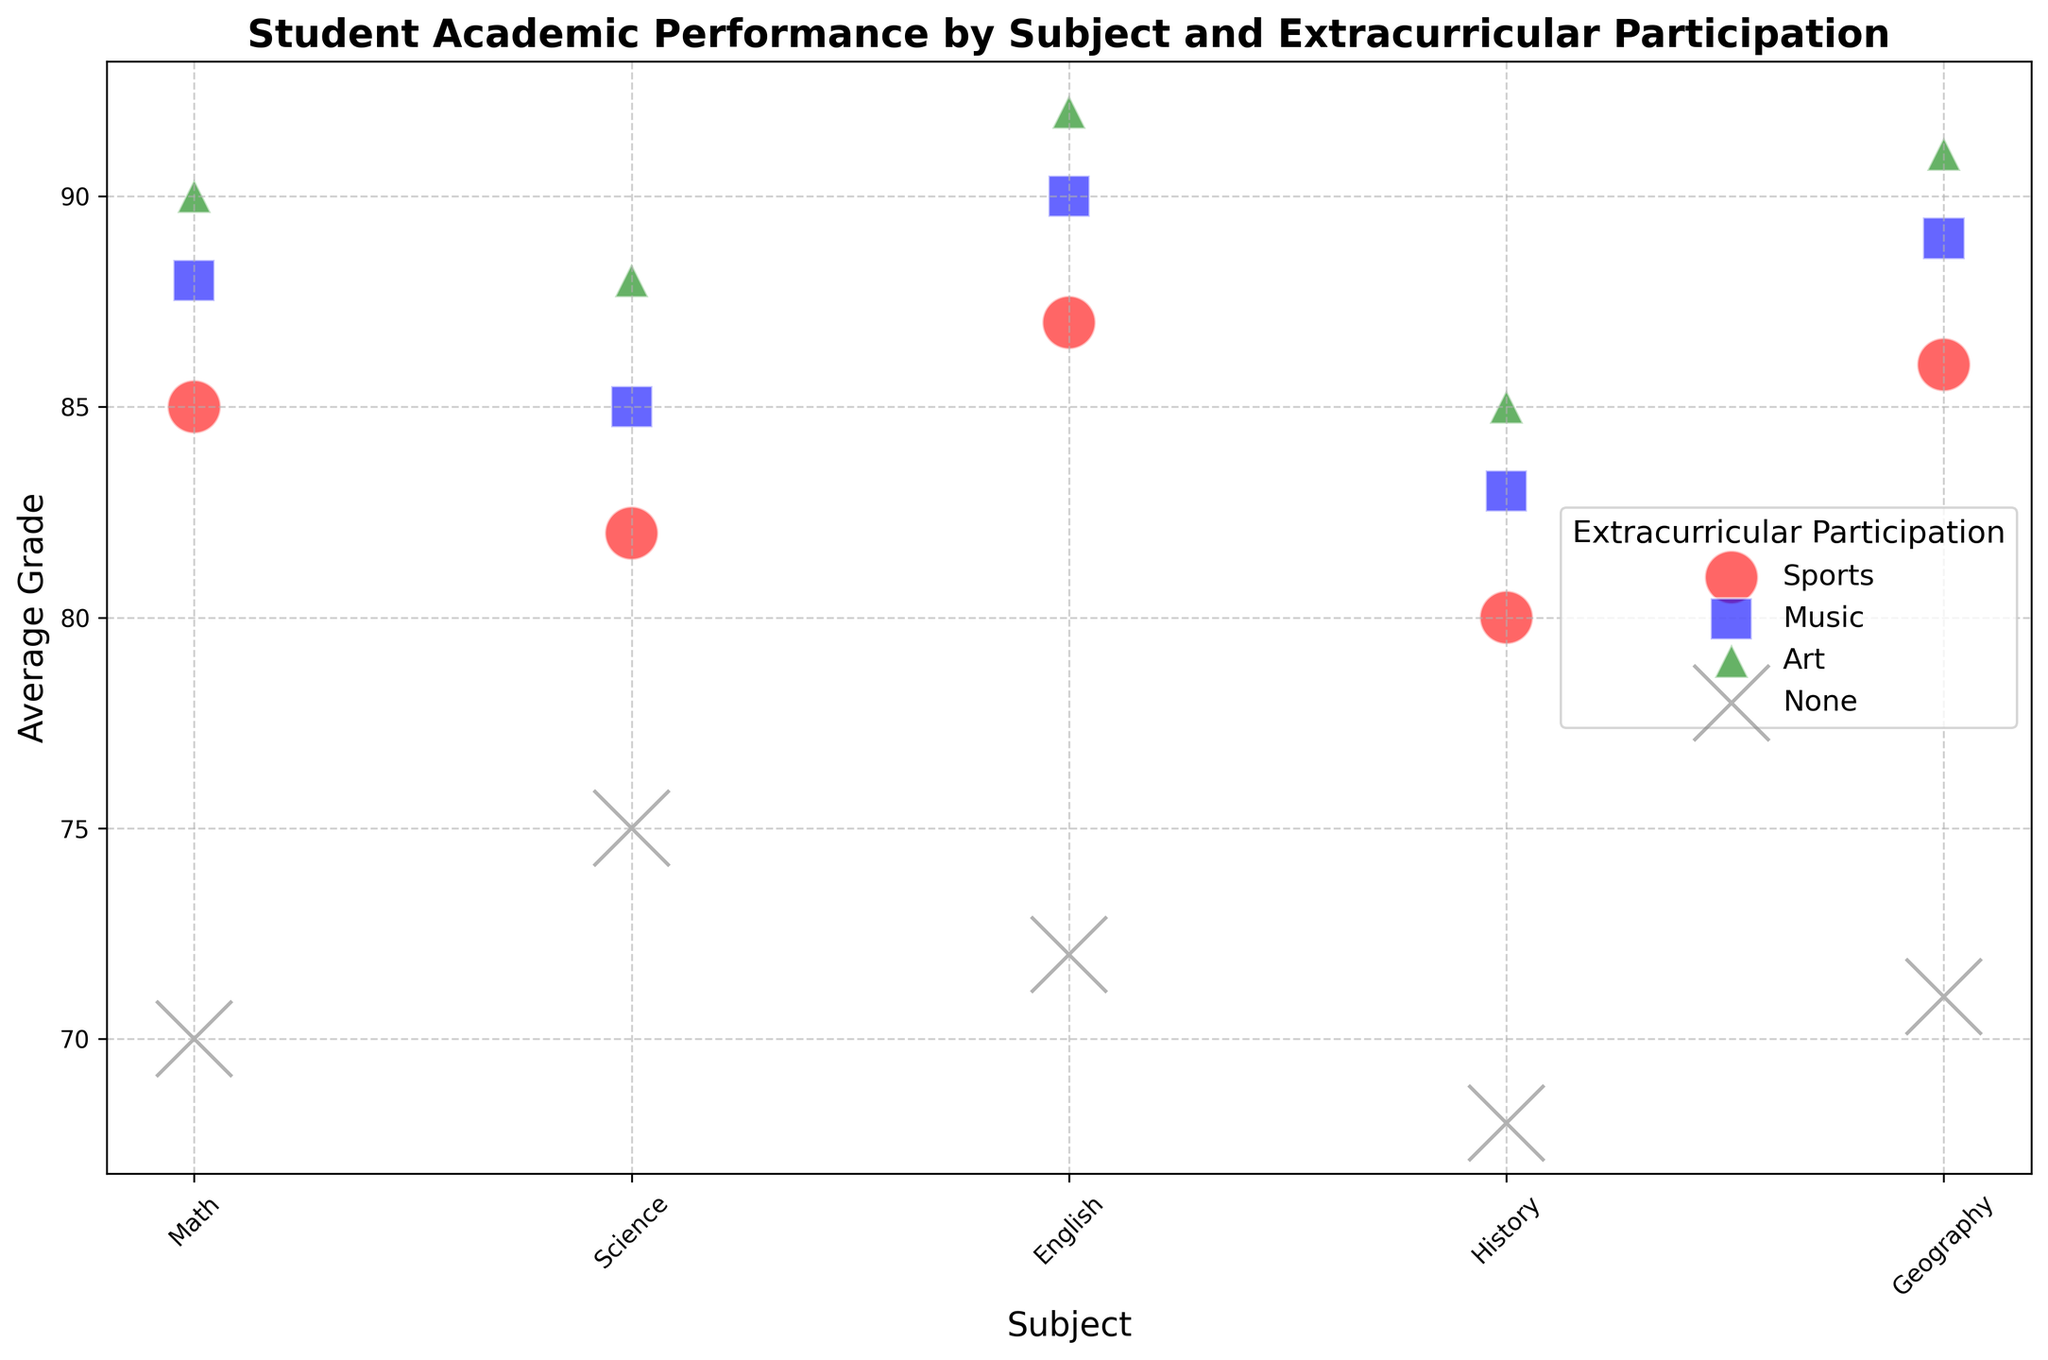Which subject has the highest average grade for students involved in sports? To find this, locate the red bubbles on the chart, which represent sports. Compare their heights (average grades). The highest red bubble on the plot represents English with an average grade of 87.
Answer: English What is the difference in average grades between students participating in art and those not involved in any extracurricular activities for Math? Identify the green (Art) and grey (None) bubbles for Math. The green bubble (Art) has an average grade of 90, and the grey bubble (None) has an average grade of 70. The difference is 90 - 70 = 20.
Answer: 20 Which extracurricular activity shows the lowest average grade for Science? Look at the bubbles for Science and identify the colors: red (Sports), blue (Music), green (Art), and grey (None). The grey (None) bubble has the lowest average grade with a value of 75.
Answer: None If you sum the number of participants involved in Music and Art for History, what is the total? Locate the bubbles for History with blue (Music) and green (Art) colors. Music has 30 participants, and Art has 20 participants. Sum them up: 30 + 20 = 50.
Answer: 50 Which subject has the smallest difference between the average grade for students involved in music and those not involved in any extracurricular activities? Compare the differences in average grades for each subject (blue versus grey bubbles). The smallest difference is for Geography, with 89 (Music) - 71 (None) = 18.
Answer: Geography What's the average grade for students in English who participate in music versus art? Identify the blue (Music) and green (Art) bubbles for English. The blue bubble (Music) has an average grade of 90, and the green bubble (Art) has an average grade of 92. The average is (90 + 92) / 2 = 91.
Answer: 91 